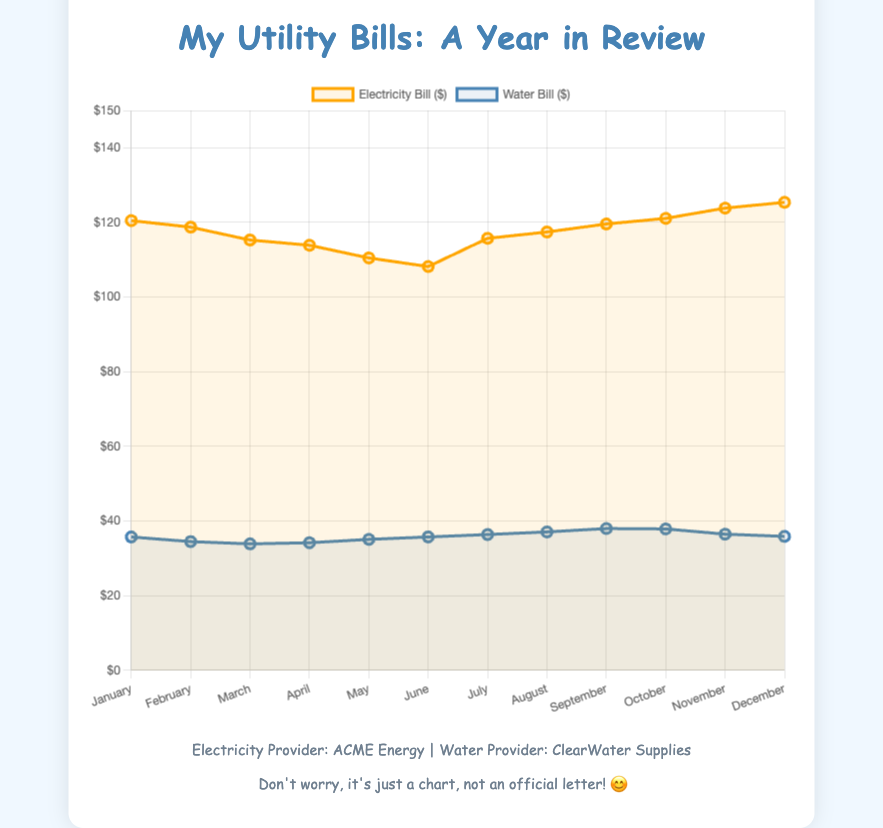What month has the highest electricity bill? The chart shows that the highest electricity bill occurs in December. The value for December is $125.40.
Answer: December Which bill is higher in June, electricity or water? By looking at the chart in June, the electricity bill is $108.20, whereas the water bill is $35.75. Therefore, the electricity bill is higher.
Answer: Electricity What is the average electricity bill from January to March? The electricity bills for January, February, and March are $120.50, $118.75, and $115.30. Calculating the average: (120.50 + 118.75 + 115.30) / 3 ≈ 118.18.
Answer: $118.18 What is the difference between the electricity bill in July and the water bill in July? The electricity bill in July is $115.75, and the water bill is $36.40. The difference is $115.75 - $36.40 = $79.35.
Answer: $79.35 Which bill exhibits more variation throughout the year, electricity or water? By observing the visual fluctuations in both lines, the electricity bill shows larger swings compared to the water bill, indicating more variation over the year.
Answer: Electricity During which month is the water bill the lowest? The chart indicates that the water bill is the lowest in March, valued at $33.90.
Answer: March In which month is the gap between electricity and water bills the smallest? Review each month's gap by subtracting the water bill number from the electricity bill number. The smallest gap appears in June: $108.20 - $35.75 = $72.45.
Answer: June What trends do the electricity and water bills show over the year? The electricity bill shows a general downward trend from January to June, an increase in July, and a peak in December. The water bill gradually increases from January to September and slightly decreases toward the year's end.
Answer: Downward then upward for electricity, upward then slight downward for water Compare the electricity bill in January and July. Which one is higher, and by how much? The electricity bill in January is $120.50, and in July, it is $115.75. The difference is $120.50 - $115.75 = $4.75, so January's bill is higher by $4.75.
Answer: January by $4.75 